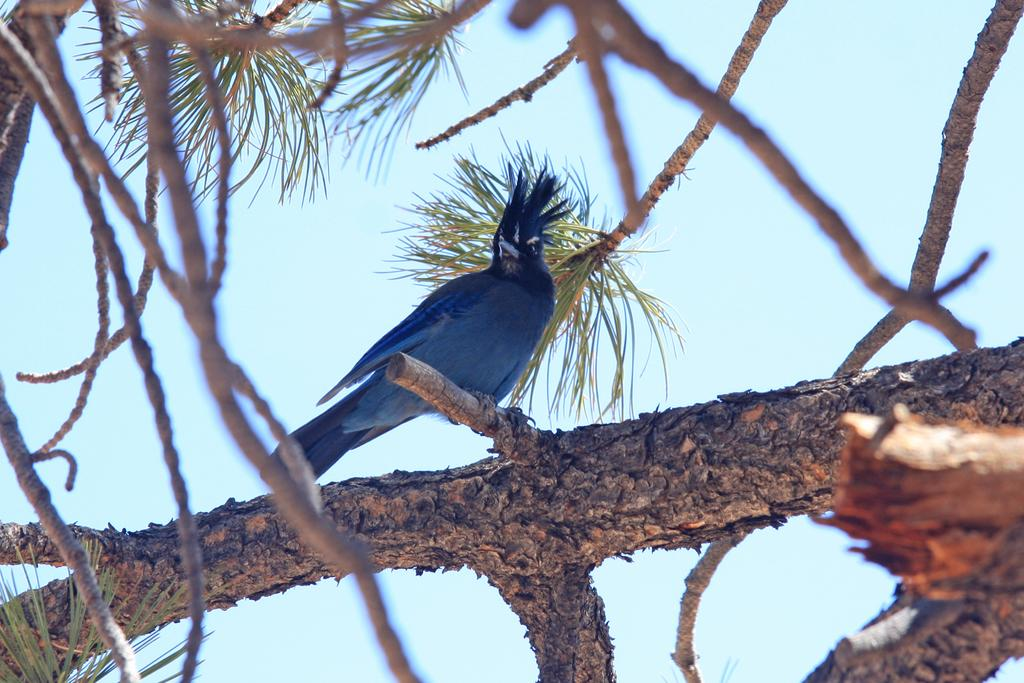What type of animal can be seen in the image? There is a bird in the image. What is the bird perched on in the image? The bird is perched on branches in the image. What else can be seen on the branches? There are stems and leaves visible on the branches in the image. What is visible in the background of the image? The sky is visible in the background of the image. What type of toothpaste is the bird using in the image? There is no toothpaste present in the image, and the bird is not using any toothpaste. 